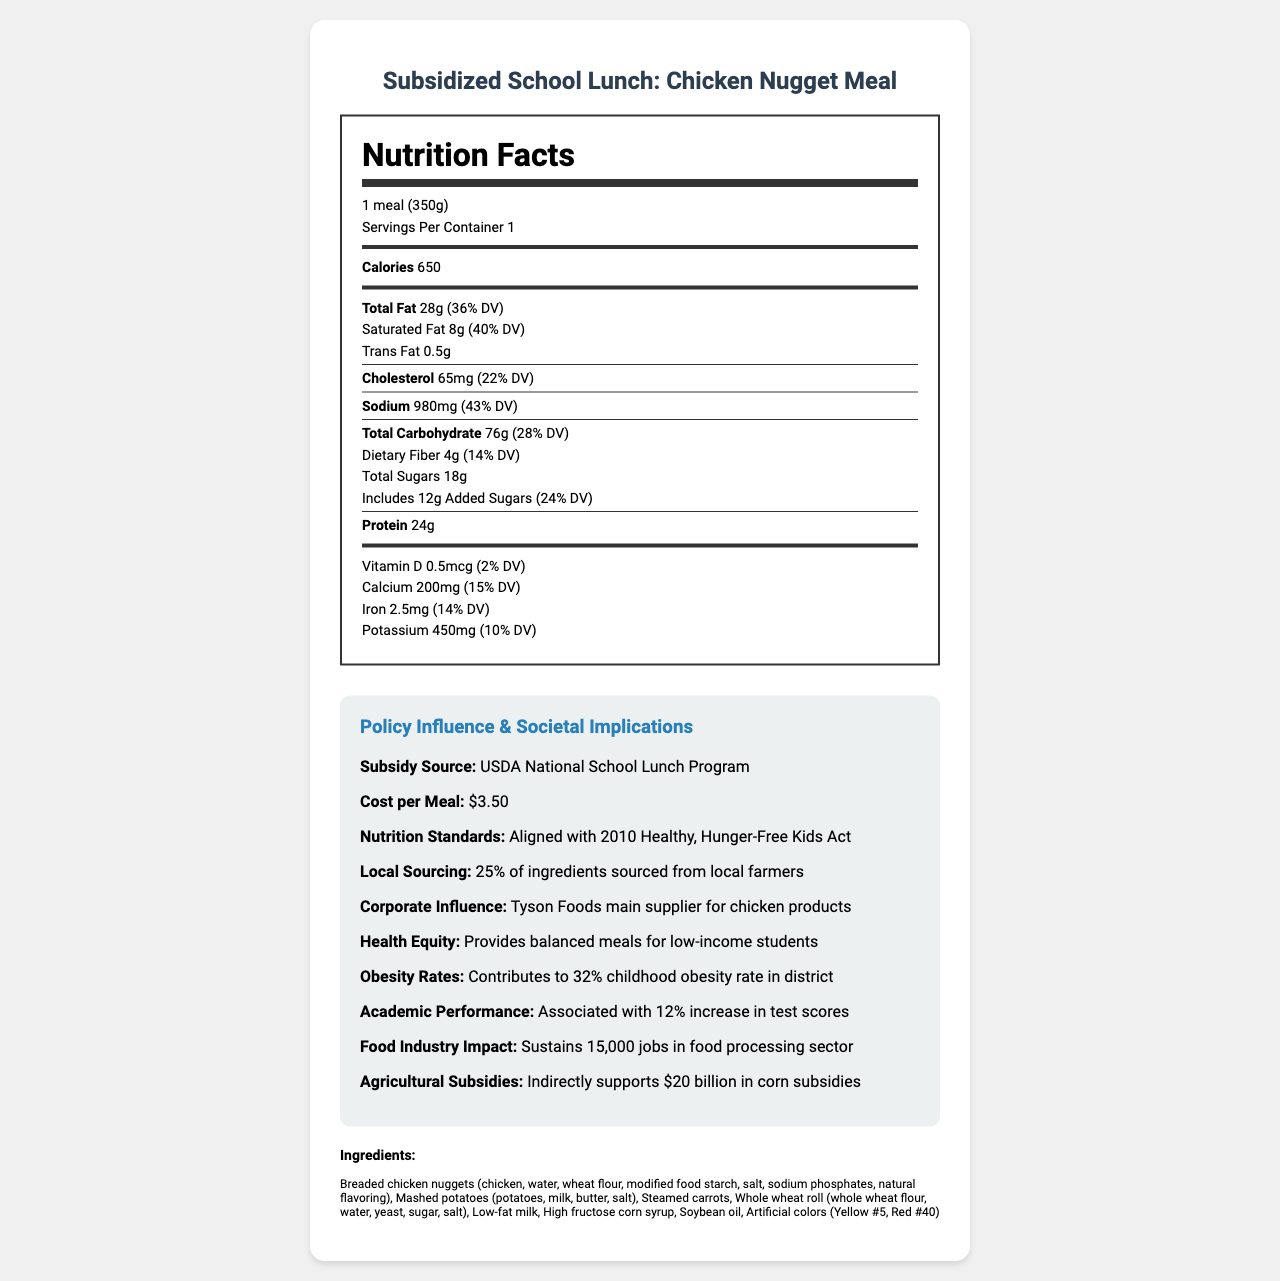what is the serving size of the Chicken Nugget Meal? The serving size is specified as "1 meal (350g)" in the document.
Answer: 1 meal (350g) what is the percentage daily value of sodium in the meal? The document notes that the sodium content of 980mg corresponds to 43% of the daily value.
Answer: 43% how much dietary fiber does the meal contain per serving? The dietary fiber content listed in the nutrition facts is 4 grams.
Answer: 4g what federal program subsidizes the Chicken Nugget Meal? The subsidy source is specified as "USDA National School Lunch Program."
Answer: USDA National School Lunch Program how many grams of total carbs are in the meal? The document states that the total carbohydrate content is 76 grams.
Answer: 76g which organization is the main supplier for chicken products in this meal? A. Perdue Farms B. Tyson Foods C. Pilgrim's Pride D. Sanderson Farms The document specifies that Tyson Foods is the main supplier for chicken products.
Answer: B. Tyson Foods what percentage of ingredients are sourced from local farmers? The document mentions that 25% of ingredients are sourced from local farmers.
Answer: 25% is the subsidy-covered meal cost effective for low-income families? Since the meal cost is $3.50 and provides balanced nutrition, it is cost-effective for low-income families.
Answer: Yes what is the main implication of this meal on childhood obesity rates? The document indicates that the meal contributes to a 32% childhood obesity rate in the district.
Answer: Contributes to 32% childhood obesity rate in district what are the economic benefits of this meal on the food processing sector? The document states that the meal sustains 15,000 jobs in the food processing sector.
Answer: Sustains 15,000 jobs in food processing sector describe the nutrition and policy-related aspects of the Chicken Nugget Meal. This summary covers the nutritional content, the subsidy source and cost, compliance with nutrition standards, local sourcing, and the broader societal and economic implications.
Answer: The Chicken Nugget Meal has 650 calories, with high levels of total fat (28g), and sodium (980mg). The meal includes key nutrients such as 24g of protein, 4g of dietary fiber, and vitamins such as iron and calcium. It is subsidized by the USDA National School Lunch Program and costs $3.50 per meal. The meal meets the 2010 Healthy, Hunger-Free Kids Act standards, sources 25% of ingredients locally, and has implications for health equity, obesity rates, academic performance, and economic impacts in the food processing sector. was the price of the meal before the subsidy included? The document only provides the subsidized cost per meal but does not mention the original price before subsidy.
Answer: Not enough information what is the effect on academic performance associated with consuming this meal? The document states that the meal is associated with a 12% increase in test scores.
Answer: 12% increase in test scores 